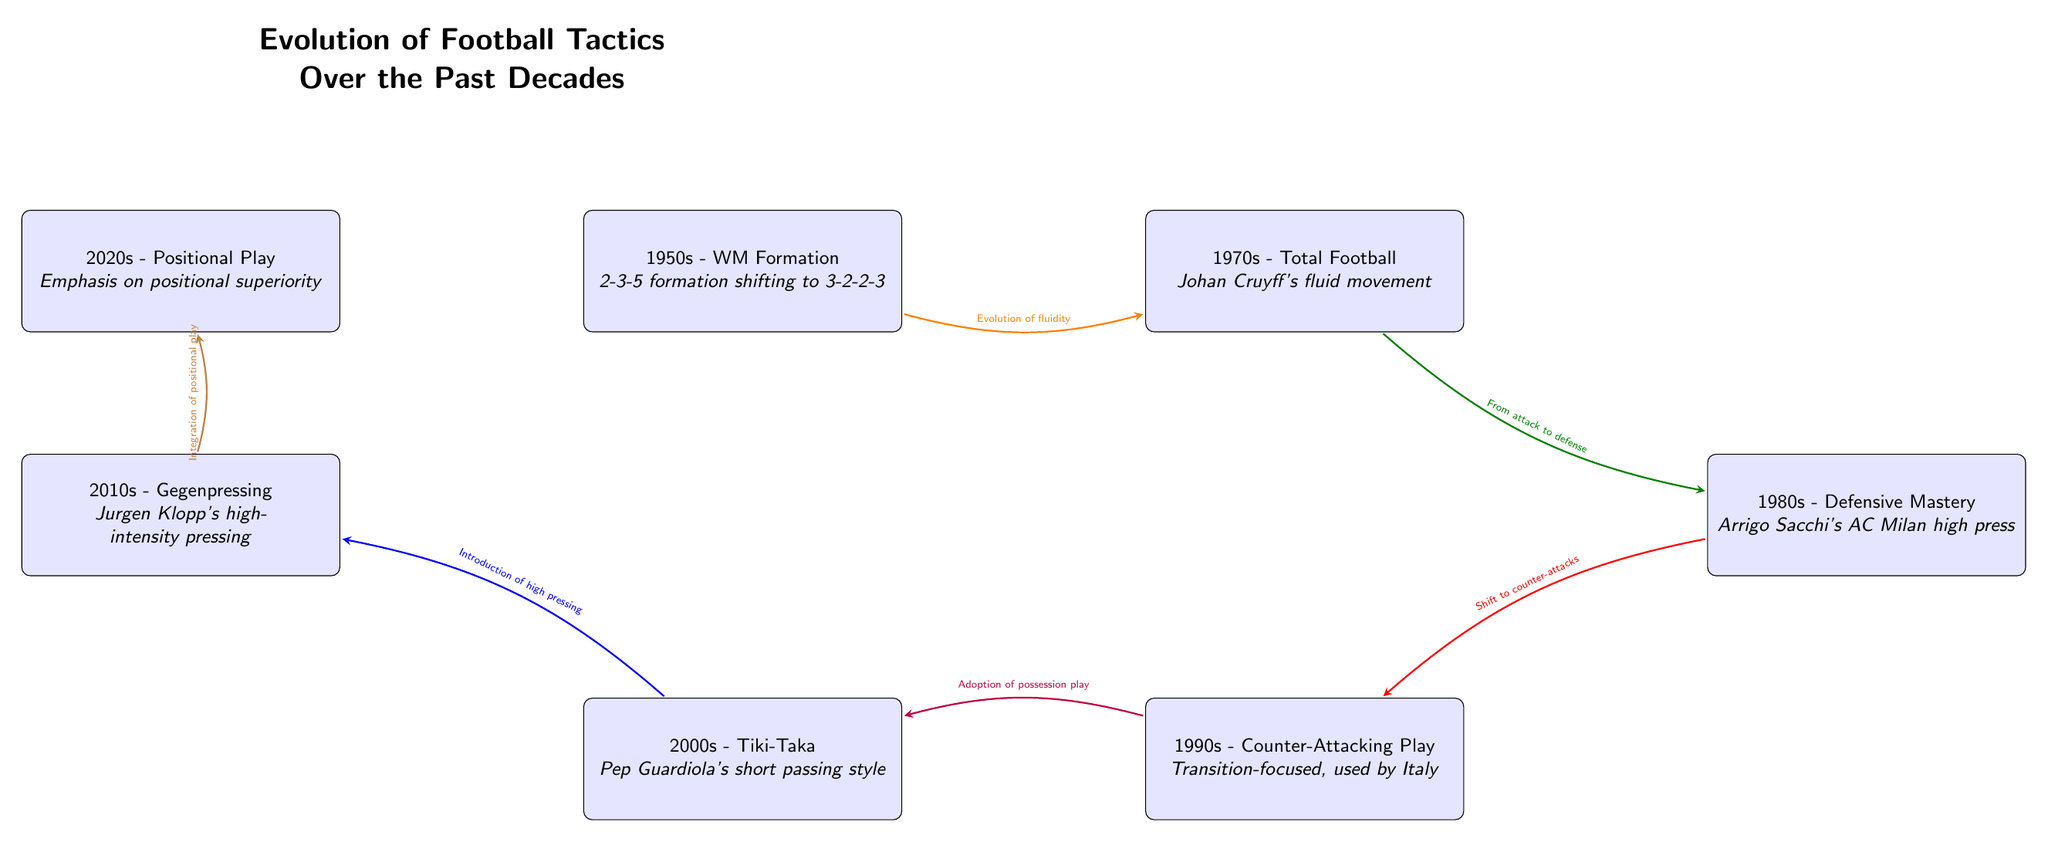What is the formation introduced in the 1950s? The diagram states that the 1950s introduced the WM Formation, indicating a shift from the 2-3-5 formation to a 3-2-2-3 formation.
Answer: WM Formation Who is associated with Total Football in the 1970s? The diagram specifies that Johan Cruyff is connected with the concept of Total Football during the 1970s, emphasizing fluid movement.
Answer: Johan Cruyff How many decades are represented in the timeline? The diagram shows information spanning six decades from the 1950s to the 2020s, marking significant shifts in football tactics.
Answer: Six What tactic emphasizes high pressing introduced in the 2010s? According to the diagram, the tactic introduced is called Gegenpressing, which focuses on high-intensity pressing strategies.
Answer: Gegenpressing What is the shift from 1990s to 2000s in terms of play style? The diagram indicates a transition from counter-attacking play in the 1990s to an emphasis on possession with Tiki-Taka in the 2000s.
Answer: Possession play What visual style connects the 1980s and 1990s? The diagram features a red arrow indicating a shift, labeled as "Shift to counter-attacks," connecting the 1980s and 1990s.
Answer: Shift to counter-attacks What term describes the emphasis on positional superiority in the 2020s? The diagram identifies the term "Positional Play" as the tactical shift emphasizing positional superiority in the 2020s.
Answer: Positional Play Which decade reflects the adoption of high pressing? The diagram shows that the 2010s is the decade that reflects the introduction and adoption of high pressing tactics.
Answer: 2010s According to the diagram, which formation emphasizes transition-focused play in the 1990s? The timeline states that in the 1990s, the focus was on Counter-Attacking Play, emphasizing transition-focused strategies primarily used by Italy.
Answer: Counter-Attacking Play 